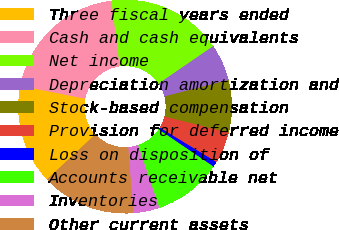Convert chart. <chart><loc_0><loc_0><loc_500><loc_500><pie_chart><fcel>Three fiscal years ended<fcel>Cash and cash equivalents<fcel>Net income<fcel>Depreciation amortization and<fcel>Stock-based compensation<fcel>Provision for deferred income<fcel>Loss on disposition of<fcel>Accounts receivable net<fcel>Inventories<fcel>Other current assets<nl><fcel>15.08%<fcel>19.84%<fcel>17.46%<fcel>5.56%<fcel>7.94%<fcel>4.76%<fcel>0.8%<fcel>10.32%<fcel>3.97%<fcel>14.28%<nl></chart> 